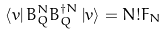Convert formula to latex. <formula><loc_0><loc_0><loc_500><loc_500>\left \langle v \right | B _ { Q } ^ { N } B _ { Q } ^ { \dag N } \left | v \right \rangle = N ! F _ { N }</formula> 